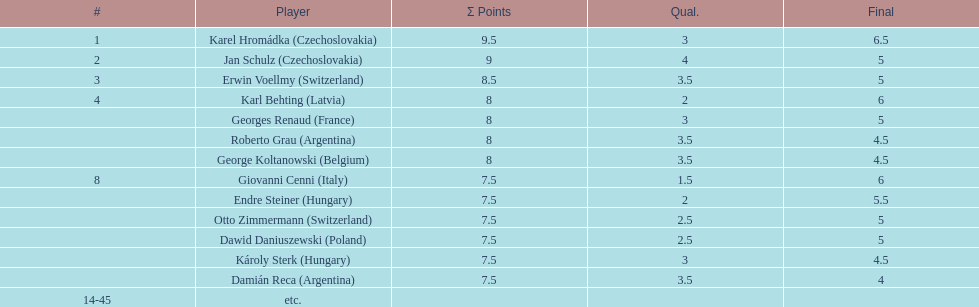Which participant had the greatest number of &#931; points? Karel Hromádka. 